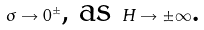<formula> <loc_0><loc_0><loc_500><loc_500>\sigma \rightarrow 0 ^ { \pm } \text {, as } H \rightarrow \pm \infty \text {.}</formula> 